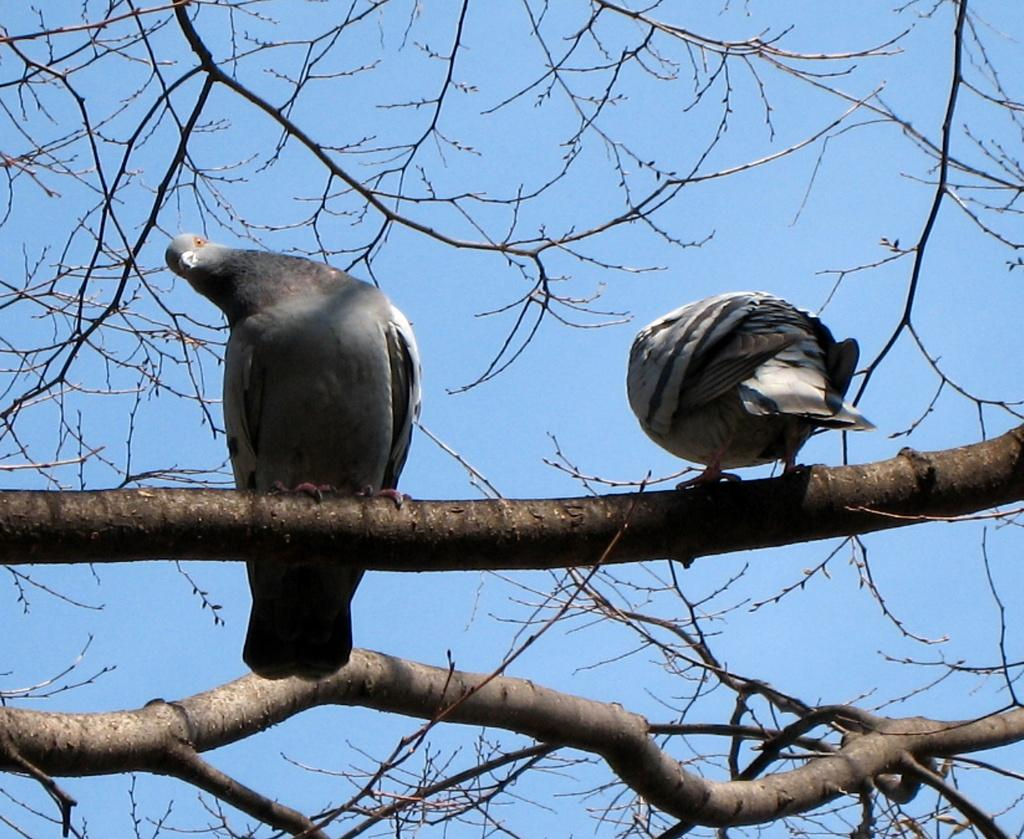What type of animals can be seen in the image? There are birds in the image. Where are the birds located in the image? The birds are on a branch of a tree. What is visible in the background of the image? The sky is visible in the image. How would you describe the sky in the image? The sky appears to be cloudy. What type of pencil is being used by the minister in the image? There is no minister or pencil present in the image; it features birds on a tree branch with a cloudy sky in the background. 